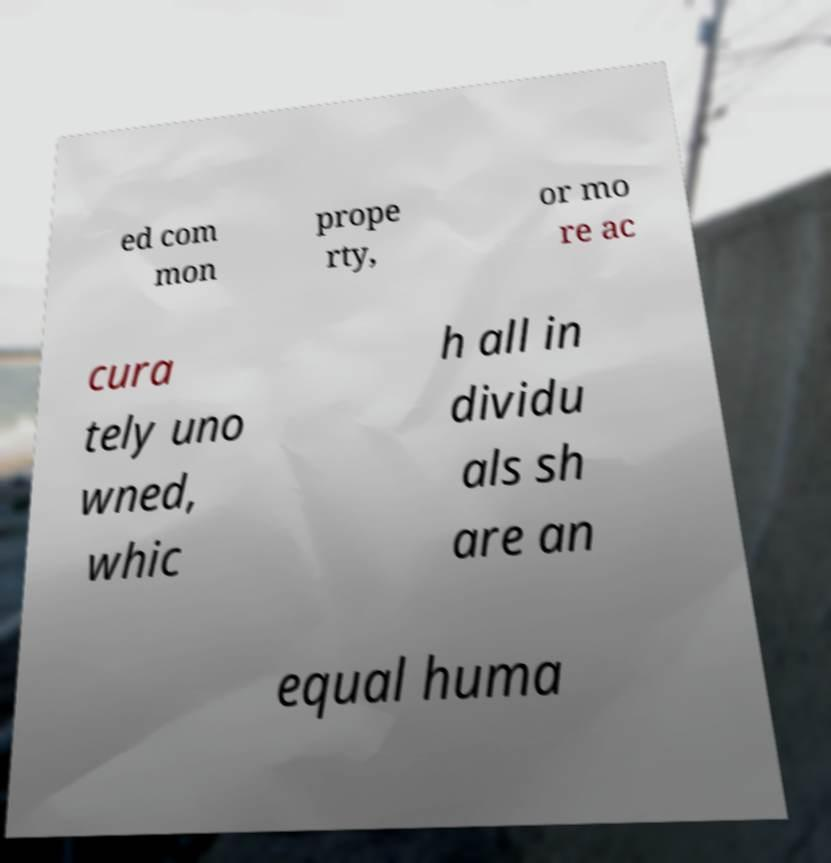Can you accurately transcribe the text from the provided image for me? ed com mon prope rty, or mo re ac cura tely uno wned, whic h all in dividu als sh are an equal huma 